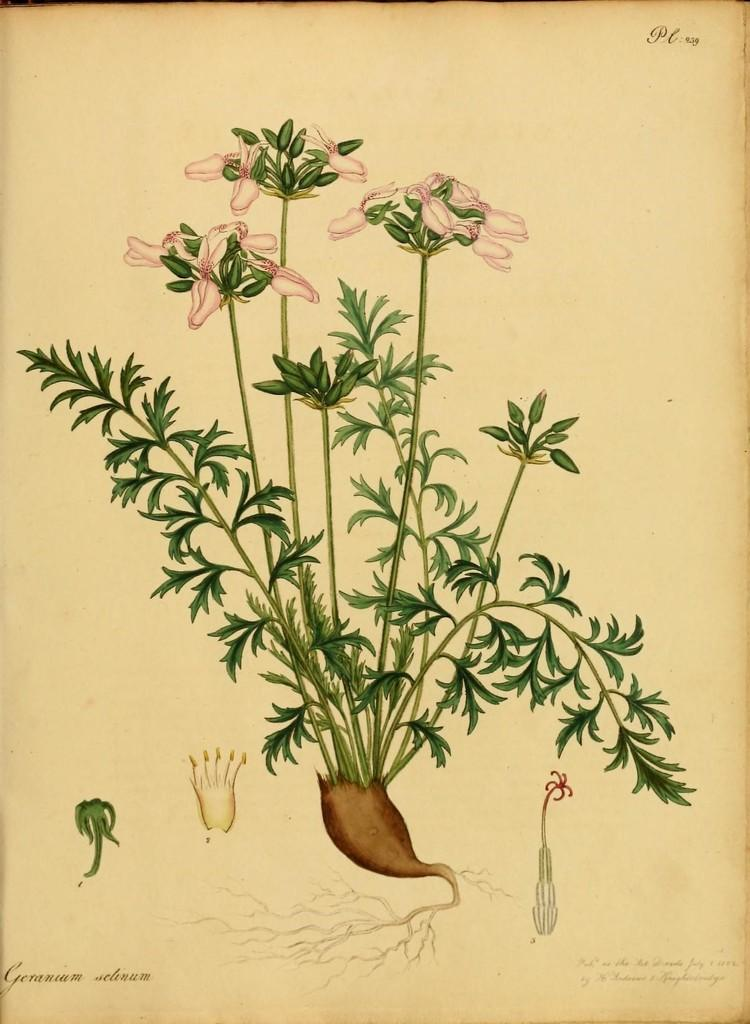What is depicted in the painting in the image? There is a painting of a tree in the image. What features of the tree can be observed in the painting? The tree in the painting has roots and flowers. Is there any text present in the image? Yes, there is text present in the image. Can you tell me how many zebras are playing chess in the image? There are no zebras or chess games present in the image; it features a painting of a tree with text. Is there a coach visible in the image? There is no coach present in the image. 